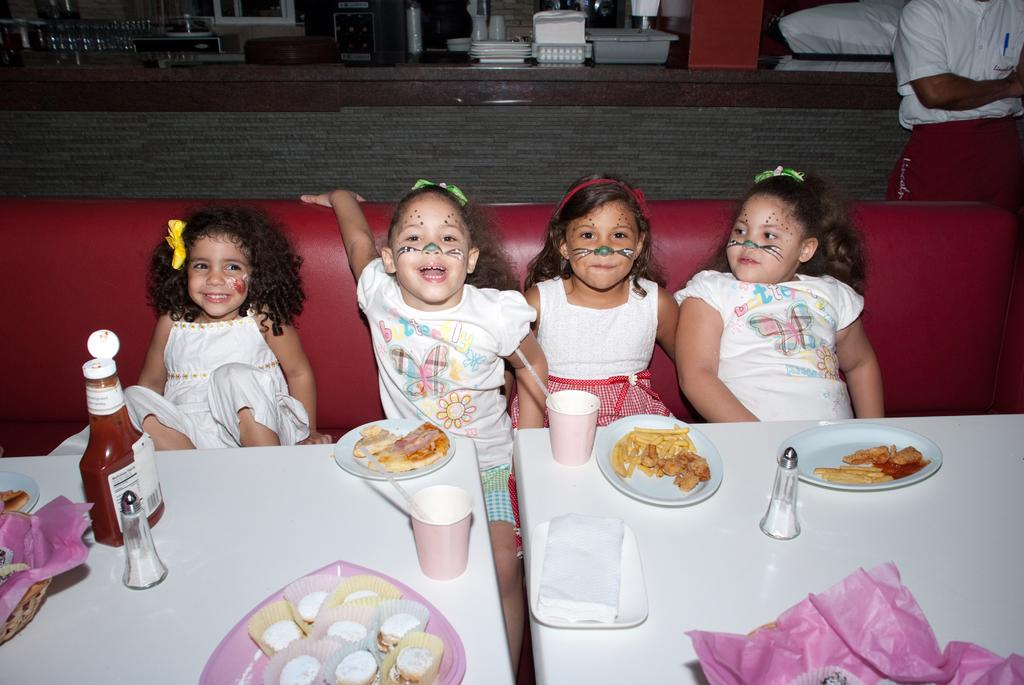How many kids are in the image? There are four girl kids in the image. What are the kids doing in the image? The kids are sitting on a sofa. What is placed in front of the kids? There is food served in plates in front of the kids. What type of frame surrounds the kids in the image? There is no frame surrounding the kids in the image; they are sitting on a sofa. How much debt do the kids have in the image? There is no mention of debt in the image; it features four kids sitting on a sofa with food served in plates in front of them. 